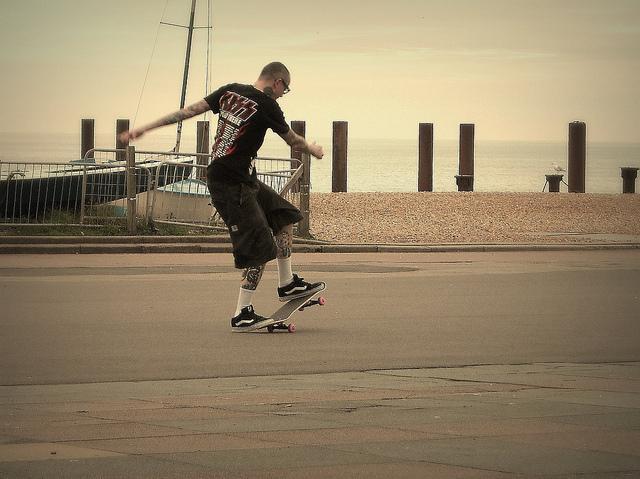How many wheels are touching the ground?
Give a very brief answer. 2. How many orange buttons on the toilet?
Give a very brief answer. 0. 